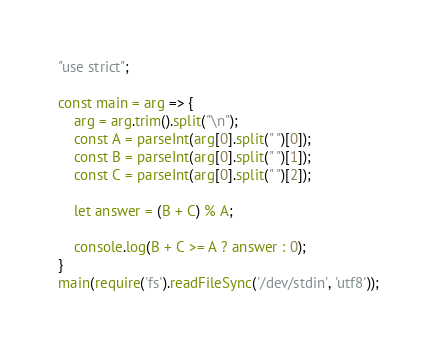<code> <loc_0><loc_0><loc_500><loc_500><_JavaScript_>"use strict";
    
const main = arg => {
    arg = arg.trim().split("\n");
    const A = parseInt(arg[0].split(" ")[0]);
    const B = parseInt(arg[0].split(" ")[1]);
    const C = parseInt(arg[0].split(" ")[2]);
    
    let answer = (B + C) % A;
    
    console.log(B + C >= A ? answer : 0);
}
main(require('fs').readFileSync('/dev/stdin', 'utf8'));
</code> 